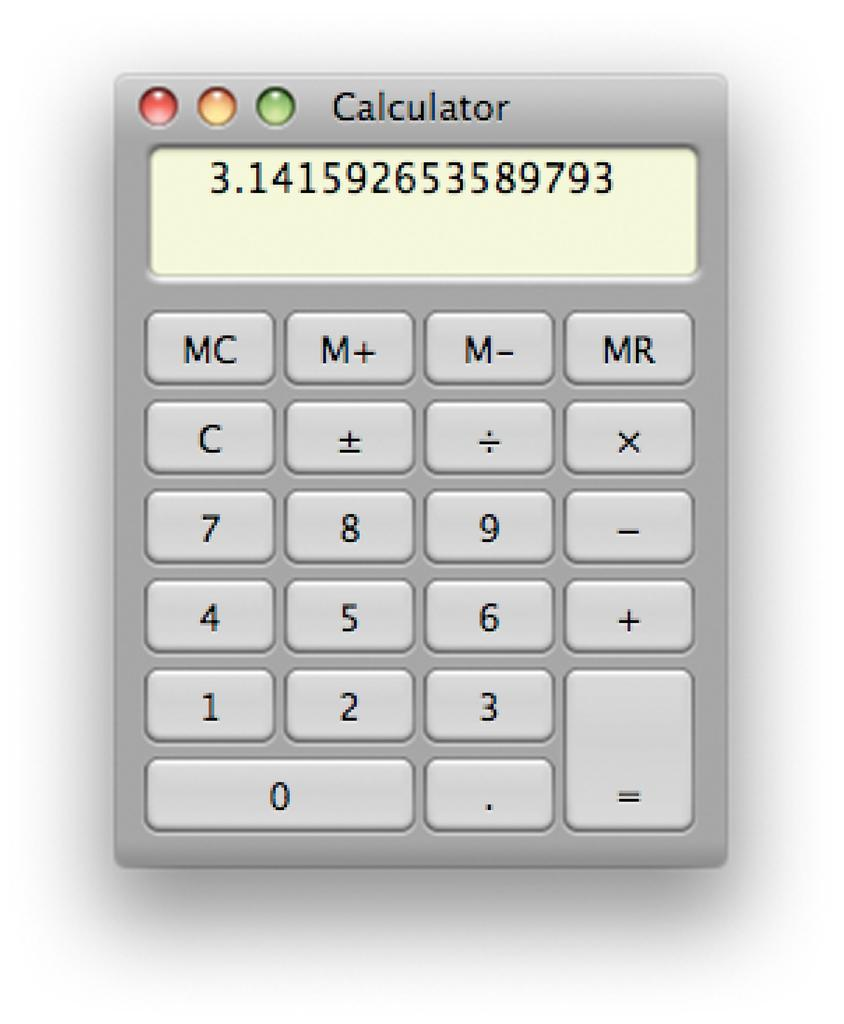<image>
Render a clear and concise summary of the photo. a calculator on a screen with the number 3.141592653589793 